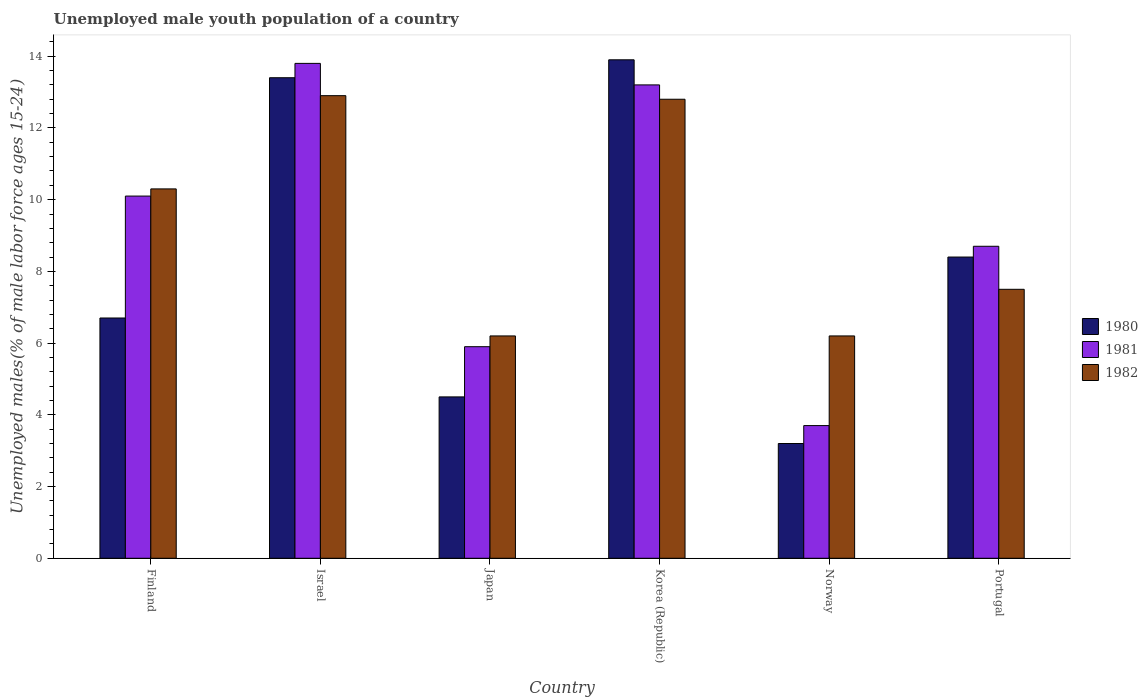How many groups of bars are there?
Make the answer very short. 6. Are the number of bars per tick equal to the number of legend labels?
Provide a succinct answer. Yes. Are the number of bars on each tick of the X-axis equal?
Provide a short and direct response. Yes. How many bars are there on the 2nd tick from the left?
Provide a short and direct response. 3. How many bars are there on the 3rd tick from the right?
Offer a very short reply. 3. What is the label of the 1st group of bars from the left?
Provide a short and direct response. Finland. In how many cases, is the number of bars for a given country not equal to the number of legend labels?
Your response must be concise. 0. What is the percentage of unemployed male youth population in 1982 in Finland?
Your response must be concise. 10.3. Across all countries, what is the maximum percentage of unemployed male youth population in 1980?
Your answer should be compact. 13.9. Across all countries, what is the minimum percentage of unemployed male youth population in 1981?
Your response must be concise. 3.7. In which country was the percentage of unemployed male youth population in 1981 maximum?
Your answer should be compact. Israel. In which country was the percentage of unemployed male youth population in 1982 minimum?
Your answer should be very brief. Japan. What is the total percentage of unemployed male youth population in 1980 in the graph?
Provide a short and direct response. 50.1. What is the difference between the percentage of unemployed male youth population in 1980 in Japan and that in Norway?
Your answer should be very brief. 1.3. What is the difference between the percentage of unemployed male youth population in 1980 in Finland and the percentage of unemployed male youth population in 1981 in Israel?
Keep it short and to the point. -7.1. What is the average percentage of unemployed male youth population in 1980 per country?
Offer a terse response. 8.35. What is the difference between the percentage of unemployed male youth population of/in 1982 and percentage of unemployed male youth population of/in 1980 in Finland?
Your answer should be compact. 3.6. What is the ratio of the percentage of unemployed male youth population in 1982 in Israel to that in Japan?
Offer a very short reply. 2.08. What is the difference between the highest and the second highest percentage of unemployed male youth population in 1981?
Make the answer very short. 3.1. What is the difference between the highest and the lowest percentage of unemployed male youth population in 1981?
Your answer should be compact. 10.1. Is the sum of the percentage of unemployed male youth population in 1981 in Norway and Portugal greater than the maximum percentage of unemployed male youth population in 1982 across all countries?
Ensure brevity in your answer.  No. What does the 1st bar from the left in Norway represents?
Provide a short and direct response. 1980. How many bars are there?
Your answer should be compact. 18. How many countries are there in the graph?
Ensure brevity in your answer.  6. What is the difference between two consecutive major ticks on the Y-axis?
Make the answer very short. 2. Does the graph contain grids?
Keep it short and to the point. No. Where does the legend appear in the graph?
Offer a terse response. Center right. What is the title of the graph?
Give a very brief answer. Unemployed male youth population of a country. Does "1972" appear as one of the legend labels in the graph?
Make the answer very short. No. What is the label or title of the Y-axis?
Make the answer very short. Unemployed males(% of male labor force ages 15-24). What is the Unemployed males(% of male labor force ages 15-24) of 1980 in Finland?
Give a very brief answer. 6.7. What is the Unemployed males(% of male labor force ages 15-24) in 1981 in Finland?
Offer a very short reply. 10.1. What is the Unemployed males(% of male labor force ages 15-24) in 1982 in Finland?
Your response must be concise. 10.3. What is the Unemployed males(% of male labor force ages 15-24) in 1980 in Israel?
Offer a terse response. 13.4. What is the Unemployed males(% of male labor force ages 15-24) of 1981 in Israel?
Your response must be concise. 13.8. What is the Unemployed males(% of male labor force ages 15-24) of 1982 in Israel?
Keep it short and to the point. 12.9. What is the Unemployed males(% of male labor force ages 15-24) of 1981 in Japan?
Make the answer very short. 5.9. What is the Unemployed males(% of male labor force ages 15-24) of 1982 in Japan?
Ensure brevity in your answer.  6.2. What is the Unemployed males(% of male labor force ages 15-24) in 1980 in Korea (Republic)?
Your response must be concise. 13.9. What is the Unemployed males(% of male labor force ages 15-24) of 1981 in Korea (Republic)?
Ensure brevity in your answer.  13.2. What is the Unemployed males(% of male labor force ages 15-24) in 1982 in Korea (Republic)?
Offer a terse response. 12.8. What is the Unemployed males(% of male labor force ages 15-24) in 1980 in Norway?
Your answer should be compact. 3.2. What is the Unemployed males(% of male labor force ages 15-24) in 1981 in Norway?
Keep it short and to the point. 3.7. What is the Unemployed males(% of male labor force ages 15-24) of 1982 in Norway?
Your response must be concise. 6.2. What is the Unemployed males(% of male labor force ages 15-24) of 1980 in Portugal?
Your response must be concise. 8.4. What is the Unemployed males(% of male labor force ages 15-24) in 1981 in Portugal?
Ensure brevity in your answer.  8.7. Across all countries, what is the maximum Unemployed males(% of male labor force ages 15-24) of 1980?
Offer a very short reply. 13.9. Across all countries, what is the maximum Unemployed males(% of male labor force ages 15-24) in 1981?
Offer a terse response. 13.8. Across all countries, what is the maximum Unemployed males(% of male labor force ages 15-24) of 1982?
Make the answer very short. 12.9. Across all countries, what is the minimum Unemployed males(% of male labor force ages 15-24) in 1980?
Give a very brief answer. 3.2. Across all countries, what is the minimum Unemployed males(% of male labor force ages 15-24) of 1981?
Make the answer very short. 3.7. Across all countries, what is the minimum Unemployed males(% of male labor force ages 15-24) of 1982?
Keep it short and to the point. 6.2. What is the total Unemployed males(% of male labor force ages 15-24) of 1980 in the graph?
Provide a short and direct response. 50.1. What is the total Unemployed males(% of male labor force ages 15-24) of 1981 in the graph?
Your answer should be very brief. 55.4. What is the total Unemployed males(% of male labor force ages 15-24) of 1982 in the graph?
Keep it short and to the point. 55.9. What is the difference between the Unemployed males(% of male labor force ages 15-24) of 1980 in Finland and that in Japan?
Provide a short and direct response. 2.2. What is the difference between the Unemployed males(% of male labor force ages 15-24) in 1982 in Finland and that in Japan?
Your response must be concise. 4.1. What is the difference between the Unemployed males(% of male labor force ages 15-24) of 1981 in Finland and that in Korea (Republic)?
Keep it short and to the point. -3.1. What is the difference between the Unemployed males(% of male labor force ages 15-24) in 1980 in Finland and that in Norway?
Give a very brief answer. 3.5. What is the difference between the Unemployed males(% of male labor force ages 15-24) of 1982 in Finland and that in Norway?
Offer a very short reply. 4.1. What is the difference between the Unemployed males(% of male labor force ages 15-24) of 1980 in Finland and that in Portugal?
Provide a succinct answer. -1.7. What is the difference between the Unemployed males(% of male labor force ages 15-24) of 1981 in Finland and that in Portugal?
Provide a short and direct response. 1.4. What is the difference between the Unemployed males(% of male labor force ages 15-24) of 1982 in Israel and that in Japan?
Your answer should be very brief. 6.7. What is the difference between the Unemployed males(% of male labor force ages 15-24) in 1981 in Israel and that in Korea (Republic)?
Ensure brevity in your answer.  0.6. What is the difference between the Unemployed males(% of male labor force ages 15-24) in 1982 in Israel and that in Norway?
Ensure brevity in your answer.  6.7. What is the difference between the Unemployed males(% of male labor force ages 15-24) of 1980 in Israel and that in Portugal?
Give a very brief answer. 5. What is the difference between the Unemployed males(% of male labor force ages 15-24) in 1981 in Israel and that in Portugal?
Your response must be concise. 5.1. What is the difference between the Unemployed males(% of male labor force ages 15-24) of 1982 in Japan and that in Korea (Republic)?
Keep it short and to the point. -6.6. What is the difference between the Unemployed males(% of male labor force ages 15-24) in 1980 in Japan and that in Norway?
Offer a terse response. 1.3. What is the difference between the Unemployed males(% of male labor force ages 15-24) in 1981 in Japan and that in Norway?
Give a very brief answer. 2.2. What is the difference between the Unemployed males(% of male labor force ages 15-24) in 1980 in Japan and that in Portugal?
Your response must be concise. -3.9. What is the difference between the Unemployed males(% of male labor force ages 15-24) of 1981 in Japan and that in Portugal?
Your answer should be very brief. -2.8. What is the difference between the Unemployed males(% of male labor force ages 15-24) in 1982 in Japan and that in Portugal?
Ensure brevity in your answer.  -1.3. What is the difference between the Unemployed males(% of male labor force ages 15-24) of 1981 in Korea (Republic) and that in Norway?
Keep it short and to the point. 9.5. What is the difference between the Unemployed males(% of male labor force ages 15-24) in 1980 in Korea (Republic) and that in Portugal?
Make the answer very short. 5.5. What is the difference between the Unemployed males(% of male labor force ages 15-24) of 1981 in Korea (Republic) and that in Portugal?
Your answer should be very brief. 4.5. What is the difference between the Unemployed males(% of male labor force ages 15-24) of 1980 in Norway and that in Portugal?
Your response must be concise. -5.2. What is the difference between the Unemployed males(% of male labor force ages 15-24) in 1982 in Norway and that in Portugal?
Offer a terse response. -1.3. What is the difference between the Unemployed males(% of male labor force ages 15-24) in 1980 in Finland and the Unemployed males(% of male labor force ages 15-24) in 1981 in Israel?
Offer a terse response. -7.1. What is the difference between the Unemployed males(% of male labor force ages 15-24) in 1980 in Finland and the Unemployed males(% of male labor force ages 15-24) in 1982 in Japan?
Provide a short and direct response. 0.5. What is the difference between the Unemployed males(% of male labor force ages 15-24) of 1981 in Finland and the Unemployed males(% of male labor force ages 15-24) of 1982 in Japan?
Keep it short and to the point. 3.9. What is the difference between the Unemployed males(% of male labor force ages 15-24) in 1980 in Finland and the Unemployed males(% of male labor force ages 15-24) in 1982 in Korea (Republic)?
Your response must be concise. -6.1. What is the difference between the Unemployed males(% of male labor force ages 15-24) of 1980 in Finland and the Unemployed males(% of male labor force ages 15-24) of 1981 in Norway?
Ensure brevity in your answer.  3. What is the difference between the Unemployed males(% of male labor force ages 15-24) in 1980 in Finland and the Unemployed males(% of male labor force ages 15-24) in 1982 in Norway?
Your answer should be very brief. 0.5. What is the difference between the Unemployed males(% of male labor force ages 15-24) in 1980 in Finland and the Unemployed males(% of male labor force ages 15-24) in 1982 in Portugal?
Provide a short and direct response. -0.8. What is the difference between the Unemployed males(% of male labor force ages 15-24) of 1981 in Finland and the Unemployed males(% of male labor force ages 15-24) of 1982 in Portugal?
Offer a very short reply. 2.6. What is the difference between the Unemployed males(% of male labor force ages 15-24) in 1980 in Israel and the Unemployed males(% of male labor force ages 15-24) in 1981 in Japan?
Offer a very short reply. 7.5. What is the difference between the Unemployed males(% of male labor force ages 15-24) of 1980 in Israel and the Unemployed males(% of male labor force ages 15-24) of 1982 in Japan?
Provide a short and direct response. 7.2. What is the difference between the Unemployed males(% of male labor force ages 15-24) of 1980 in Israel and the Unemployed males(% of male labor force ages 15-24) of 1982 in Korea (Republic)?
Provide a short and direct response. 0.6. What is the difference between the Unemployed males(% of male labor force ages 15-24) of 1981 in Israel and the Unemployed males(% of male labor force ages 15-24) of 1982 in Korea (Republic)?
Make the answer very short. 1. What is the difference between the Unemployed males(% of male labor force ages 15-24) in 1980 in Israel and the Unemployed males(% of male labor force ages 15-24) in 1981 in Norway?
Keep it short and to the point. 9.7. What is the difference between the Unemployed males(% of male labor force ages 15-24) of 1980 in Israel and the Unemployed males(% of male labor force ages 15-24) of 1982 in Norway?
Ensure brevity in your answer.  7.2. What is the difference between the Unemployed males(% of male labor force ages 15-24) in 1981 in Israel and the Unemployed males(% of male labor force ages 15-24) in 1982 in Norway?
Your response must be concise. 7.6. What is the difference between the Unemployed males(% of male labor force ages 15-24) of 1980 in Israel and the Unemployed males(% of male labor force ages 15-24) of 1981 in Portugal?
Keep it short and to the point. 4.7. What is the difference between the Unemployed males(% of male labor force ages 15-24) in 1980 in Israel and the Unemployed males(% of male labor force ages 15-24) in 1982 in Portugal?
Provide a succinct answer. 5.9. What is the difference between the Unemployed males(% of male labor force ages 15-24) in 1981 in Japan and the Unemployed males(% of male labor force ages 15-24) in 1982 in Korea (Republic)?
Your response must be concise. -6.9. What is the difference between the Unemployed males(% of male labor force ages 15-24) in 1980 in Japan and the Unemployed males(% of male labor force ages 15-24) in 1982 in Norway?
Provide a short and direct response. -1.7. What is the difference between the Unemployed males(% of male labor force ages 15-24) of 1981 in Japan and the Unemployed males(% of male labor force ages 15-24) of 1982 in Norway?
Offer a terse response. -0.3. What is the difference between the Unemployed males(% of male labor force ages 15-24) in 1980 in Japan and the Unemployed males(% of male labor force ages 15-24) in 1982 in Portugal?
Offer a very short reply. -3. What is the difference between the Unemployed males(% of male labor force ages 15-24) in 1981 in Japan and the Unemployed males(% of male labor force ages 15-24) in 1982 in Portugal?
Provide a short and direct response. -1.6. What is the difference between the Unemployed males(% of male labor force ages 15-24) of 1980 in Korea (Republic) and the Unemployed males(% of male labor force ages 15-24) of 1981 in Norway?
Your response must be concise. 10.2. What is the difference between the Unemployed males(% of male labor force ages 15-24) of 1980 in Korea (Republic) and the Unemployed males(% of male labor force ages 15-24) of 1982 in Portugal?
Provide a short and direct response. 6.4. What is the average Unemployed males(% of male labor force ages 15-24) in 1980 per country?
Provide a short and direct response. 8.35. What is the average Unemployed males(% of male labor force ages 15-24) of 1981 per country?
Ensure brevity in your answer.  9.23. What is the average Unemployed males(% of male labor force ages 15-24) of 1982 per country?
Make the answer very short. 9.32. What is the difference between the Unemployed males(% of male labor force ages 15-24) of 1980 and Unemployed males(% of male labor force ages 15-24) of 1982 in Finland?
Offer a very short reply. -3.6. What is the difference between the Unemployed males(% of male labor force ages 15-24) in 1980 and Unemployed males(% of male labor force ages 15-24) in 1981 in Israel?
Your response must be concise. -0.4. What is the difference between the Unemployed males(% of male labor force ages 15-24) of 1980 and Unemployed males(% of male labor force ages 15-24) of 1982 in Israel?
Offer a very short reply. 0.5. What is the difference between the Unemployed males(% of male labor force ages 15-24) of 1980 and Unemployed males(% of male labor force ages 15-24) of 1981 in Japan?
Make the answer very short. -1.4. What is the difference between the Unemployed males(% of male labor force ages 15-24) of 1981 and Unemployed males(% of male labor force ages 15-24) of 1982 in Japan?
Keep it short and to the point. -0.3. What is the difference between the Unemployed males(% of male labor force ages 15-24) in 1980 and Unemployed males(% of male labor force ages 15-24) in 1981 in Korea (Republic)?
Your answer should be very brief. 0.7. What is the difference between the Unemployed males(% of male labor force ages 15-24) of 1981 and Unemployed males(% of male labor force ages 15-24) of 1982 in Korea (Republic)?
Offer a very short reply. 0.4. What is the difference between the Unemployed males(% of male labor force ages 15-24) of 1980 and Unemployed males(% of male labor force ages 15-24) of 1982 in Norway?
Offer a very short reply. -3. What is the difference between the Unemployed males(% of male labor force ages 15-24) in 1981 and Unemployed males(% of male labor force ages 15-24) in 1982 in Norway?
Your answer should be very brief. -2.5. What is the difference between the Unemployed males(% of male labor force ages 15-24) in 1980 and Unemployed males(% of male labor force ages 15-24) in 1981 in Portugal?
Make the answer very short. -0.3. What is the difference between the Unemployed males(% of male labor force ages 15-24) of 1981 and Unemployed males(% of male labor force ages 15-24) of 1982 in Portugal?
Make the answer very short. 1.2. What is the ratio of the Unemployed males(% of male labor force ages 15-24) of 1980 in Finland to that in Israel?
Offer a terse response. 0.5. What is the ratio of the Unemployed males(% of male labor force ages 15-24) of 1981 in Finland to that in Israel?
Keep it short and to the point. 0.73. What is the ratio of the Unemployed males(% of male labor force ages 15-24) of 1982 in Finland to that in Israel?
Offer a terse response. 0.8. What is the ratio of the Unemployed males(% of male labor force ages 15-24) in 1980 in Finland to that in Japan?
Offer a terse response. 1.49. What is the ratio of the Unemployed males(% of male labor force ages 15-24) in 1981 in Finland to that in Japan?
Provide a succinct answer. 1.71. What is the ratio of the Unemployed males(% of male labor force ages 15-24) in 1982 in Finland to that in Japan?
Ensure brevity in your answer.  1.66. What is the ratio of the Unemployed males(% of male labor force ages 15-24) of 1980 in Finland to that in Korea (Republic)?
Make the answer very short. 0.48. What is the ratio of the Unemployed males(% of male labor force ages 15-24) of 1981 in Finland to that in Korea (Republic)?
Ensure brevity in your answer.  0.77. What is the ratio of the Unemployed males(% of male labor force ages 15-24) of 1982 in Finland to that in Korea (Republic)?
Make the answer very short. 0.8. What is the ratio of the Unemployed males(% of male labor force ages 15-24) of 1980 in Finland to that in Norway?
Keep it short and to the point. 2.09. What is the ratio of the Unemployed males(% of male labor force ages 15-24) of 1981 in Finland to that in Norway?
Give a very brief answer. 2.73. What is the ratio of the Unemployed males(% of male labor force ages 15-24) in 1982 in Finland to that in Norway?
Provide a succinct answer. 1.66. What is the ratio of the Unemployed males(% of male labor force ages 15-24) of 1980 in Finland to that in Portugal?
Provide a short and direct response. 0.8. What is the ratio of the Unemployed males(% of male labor force ages 15-24) in 1981 in Finland to that in Portugal?
Offer a terse response. 1.16. What is the ratio of the Unemployed males(% of male labor force ages 15-24) of 1982 in Finland to that in Portugal?
Ensure brevity in your answer.  1.37. What is the ratio of the Unemployed males(% of male labor force ages 15-24) in 1980 in Israel to that in Japan?
Make the answer very short. 2.98. What is the ratio of the Unemployed males(% of male labor force ages 15-24) in 1981 in Israel to that in Japan?
Offer a terse response. 2.34. What is the ratio of the Unemployed males(% of male labor force ages 15-24) in 1982 in Israel to that in Japan?
Offer a very short reply. 2.08. What is the ratio of the Unemployed males(% of male labor force ages 15-24) of 1980 in Israel to that in Korea (Republic)?
Give a very brief answer. 0.96. What is the ratio of the Unemployed males(% of male labor force ages 15-24) of 1981 in Israel to that in Korea (Republic)?
Give a very brief answer. 1.05. What is the ratio of the Unemployed males(% of male labor force ages 15-24) of 1980 in Israel to that in Norway?
Your answer should be very brief. 4.19. What is the ratio of the Unemployed males(% of male labor force ages 15-24) in 1981 in Israel to that in Norway?
Make the answer very short. 3.73. What is the ratio of the Unemployed males(% of male labor force ages 15-24) of 1982 in Israel to that in Norway?
Keep it short and to the point. 2.08. What is the ratio of the Unemployed males(% of male labor force ages 15-24) of 1980 in Israel to that in Portugal?
Give a very brief answer. 1.6. What is the ratio of the Unemployed males(% of male labor force ages 15-24) in 1981 in Israel to that in Portugal?
Keep it short and to the point. 1.59. What is the ratio of the Unemployed males(% of male labor force ages 15-24) in 1982 in Israel to that in Portugal?
Your answer should be very brief. 1.72. What is the ratio of the Unemployed males(% of male labor force ages 15-24) of 1980 in Japan to that in Korea (Republic)?
Offer a very short reply. 0.32. What is the ratio of the Unemployed males(% of male labor force ages 15-24) in 1981 in Japan to that in Korea (Republic)?
Keep it short and to the point. 0.45. What is the ratio of the Unemployed males(% of male labor force ages 15-24) in 1982 in Japan to that in Korea (Republic)?
Your answer should be very brief. 0.48. What is the ratio of the Unemployed males(% of male labor force ages 15-24) of 1980 in Japan to that in Norway?
Make the answer very short. 1.41. What is the ratio of the Unemployed males(% of male labor force ages 15-24) of 1981 in Japan to that in Norway?
Provide a short and direct response. 1.59. What is the ratio of the Unemployed males(% of male labor force ages 15-24) of 1980 in Japan to that in Portugal?
Provide a short and direct response. 0.54. What is the ratio of the Unemployed males(% of male labor force ages 15-24) in 1981 in Japan to that in Portugal?
Make the answer very short. 0.68. What is the ratio of the Unemployed males(% of male labor force ages 15-24) in 1982 in Japan to that in Portugal?
Your answer should be compact. 0.83. What is the ratio of the Unemployed males(% of male labor force ages 15-24) of 1980 in Korea (Republic) to that in Norway?
Give a very brief answer. 4.34. What is the ratio of the Unemployed males(% of male labor force ages 15-24) of 1981 in Korea (Republic) to that in Norway?
Your answer should be very brief. 3.57. What is the ratio of the Unemployed males(% of male labor force ages 15-24) of 1982 in Korea (Republic) to that in Norway?
Ensure brevity in your answer.  2.06. What is the ratio of the Unemployed males(% of male labor force ages 15-24) in 1980 in Korea (Republic) to that in Portugal?
Give a very brief answer. 1.65. What is the ratio of the Unemployed males(% of male labor force ages 15-24) of 1981 in Korea (Republic) to that in Portugal?
Your response must be concise. 1.52. What is the ratio of the Unemployed males(% of male labor force ages 15-24) in 1982 in Korea (Republic) to that in Portugal?
Provide a succinct answer. 1.71. What is the ratio of the Unemployed males(% of male labor force ages 15-24) in 1980 in Norway to that in Portugal?
Make the answer very short. 0.38. What is the ratio of the Unemployed males(% of male labor force ages 15-24) of 1981 in Norway to that in Portugal?
Make the answer very short. 0.43. What is the ratio of the Unemployed males(% of male labor force ages 15-24) of 1982 in Norway to that in Portugal?
Give a very brief answer. 0.83. What is the difference between the highest and the second highest Unemployed males(% of male labor force ages 15-24) of 1980?
Your response must be concise. 0.5. What is the difference between the highest and the second highest Unemployed males(% of male labor force ages 15-24) in 1981?
Provide a short and direct response. 0.6. What is the difference between the highest and the lowest Unemployed males(% of male labor force ages 15-24) of 1982?
Your response must be concise. 6.7. 